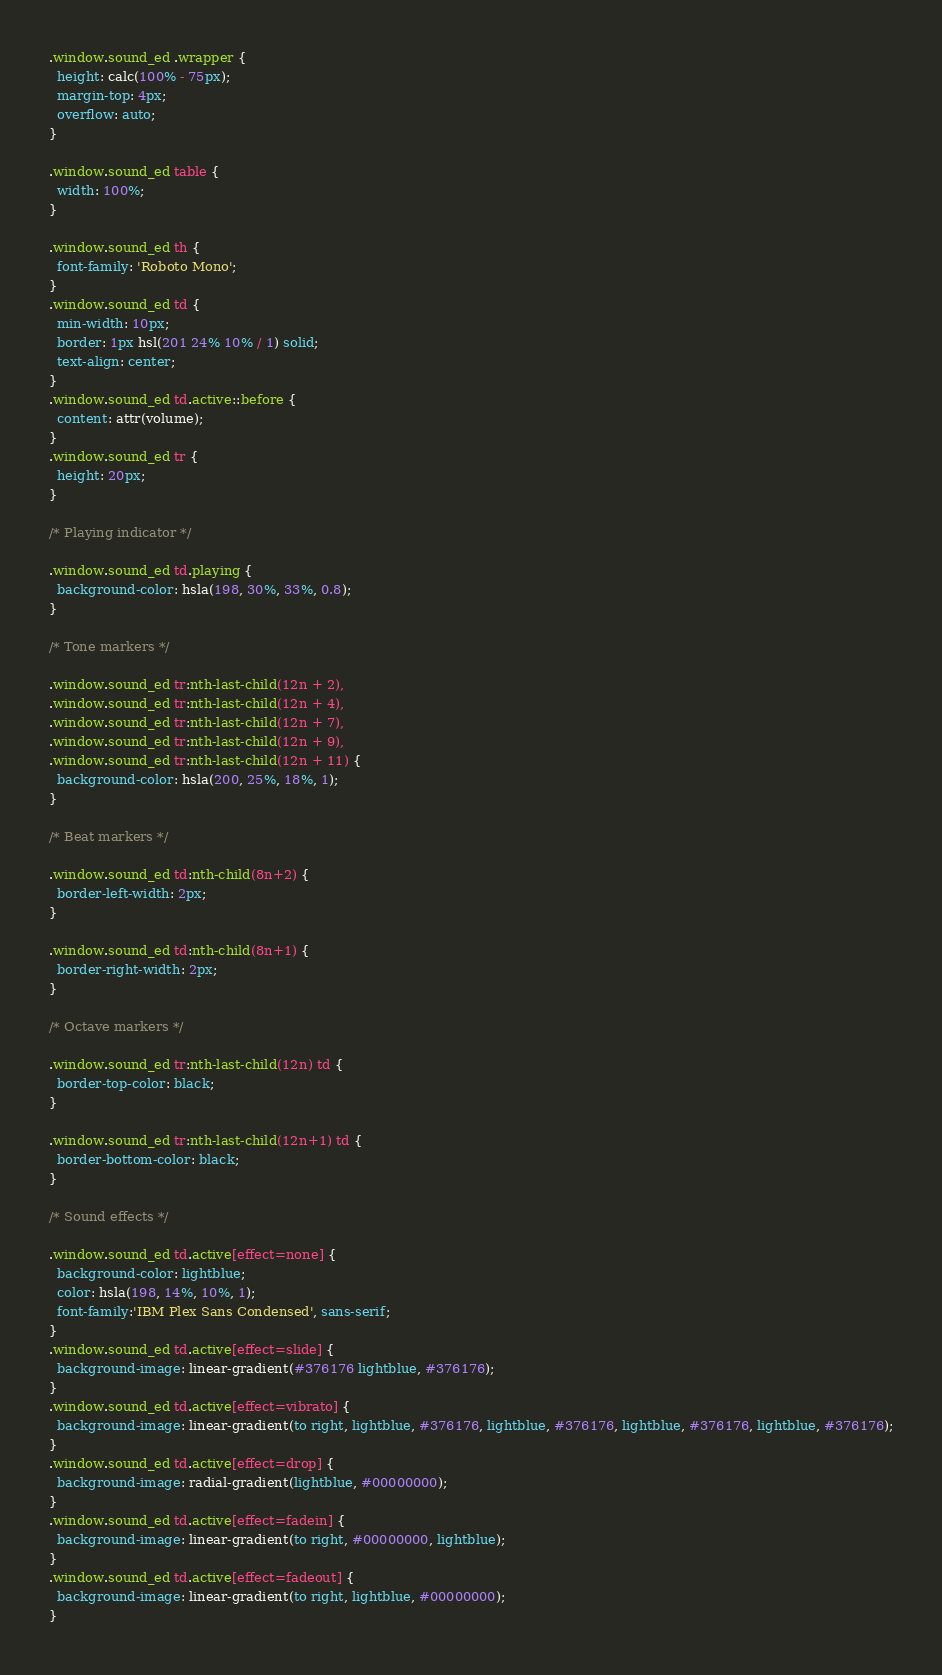<code> <loc_0><loc_0><loc_500><loc_500><_CSS_>.window.sound_ed .wrapper {
  height: calc(100% - 75px);
  margin-top: 4px;
  overflow: auto;
}

.window.sound_ed table {
  width: 100%;
}

.window.sound_ed th {
  font-family: 'Roboto Mono';
}
.window.sound_ed td {
  min-width: 10px;
  border: 1px hsl(201 24% 10% / 1) solid;
  text-align: center;
}
.window.sound_ed td.active::before {
  content: attr(volume);
}
.window.sound_ed tr {
  height: 20px;
}

/* Playing indicator */

.window.sound_ed td.playing {
  background-color: hsla(198, 30%, 33%, 0.8);
}

/* Tone markers */

.window.sound_ed tr:nth-last-child(12n + 2),
.window.sound_ed tr:nth-last-child(12n + 4),
.window.sound_ed tr:nth-last-child(12n + 7),
.window.sound_ed tr:nth-last-child(12n + 9),
.window.sound_ed tr:nth-last-child(12n + 11) {
  background-color: hsla(200, 25%, 18%, 1);
}

/* Beat markers */

.window.sound_ed td:nth-child(8n+2) {
  border-left-width: 2px;
}

.window.sound_ed td:nth-child(8n+1) {
  border-right-width: 2px;
}

/* Octave markers */

.window.sound_ed tr:nth-last-child(12n) td {
  border-top-color: black;
}

.window.sound_ed tr:nth-last-child(12n+1) td {
  border-bottom-color: black;
}

/* Sound effects */

.window.sound_ed td.active[effect=none] {
  background-color: lightblue;
  color: hsla(198, 14%, 10%, 1);
  font-family:'IBM Plex Sans Condensed', sans-serif;
}
.window.sound_ed td.active[effect=slide] {
  background-image: linear-gradient(#376176 lightblue, #376176);
}
.window.sound_ed td.active[effect=vibrato] {
  background-image: linear-gradient(to right, lightblue, #376176, lightblue, #376176, lightblue, #376176, lightblue, #376176);
}
.window.sound_ed td.active[effect=drop] {
  background-image: radial-gradient(lightblue, #00000000);
}
.window.sound_ed td.active[effect=fadein] {
  background-image: linear-gradient(to right, #00000000, lightblue);
}
.window.sound_ed td.active[effect=fadeout] {
  background-image: linear-gradient(to right, lightblue, #00000000);
}
</code> 